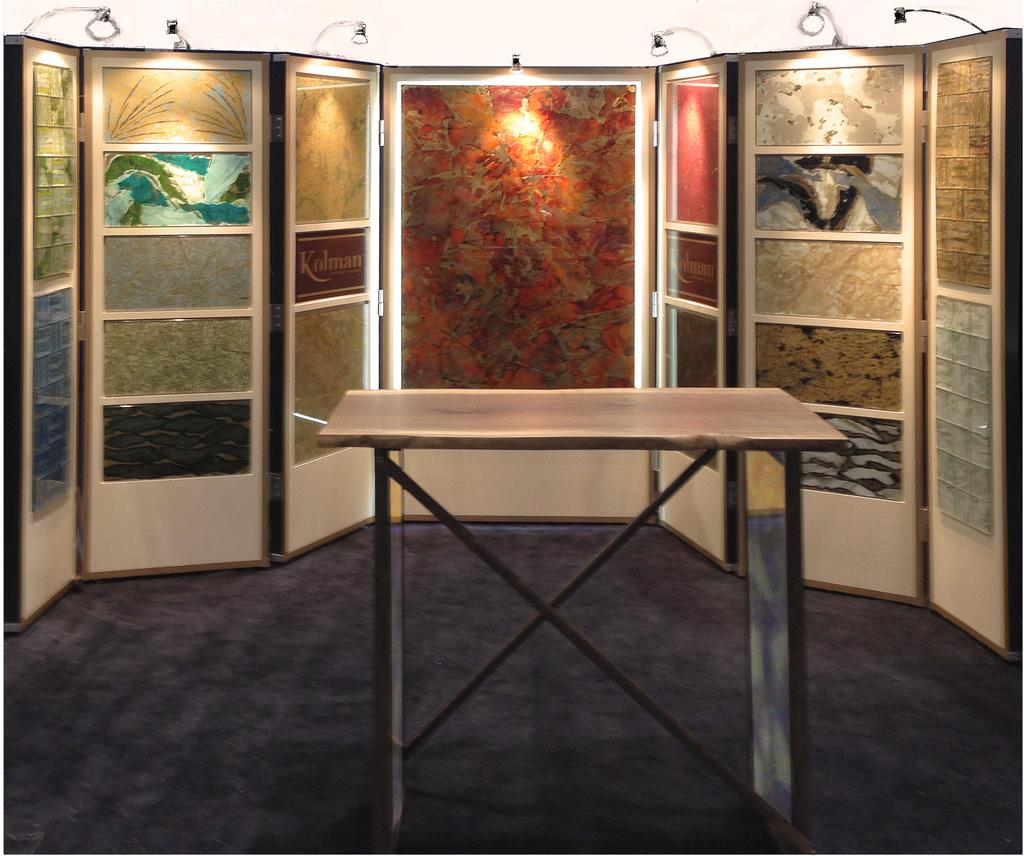What is located in the middle of the image? There is a table in the middle of the image. What can be seen on the wall in the background? There are paintings on the wall in the background. What is visible at the top of the image? There are lights visible at the top of the image. What type of mist can be seen falling from the lights in the image? There is no mist present in the image; the lights are visible without any mist falling from them. 